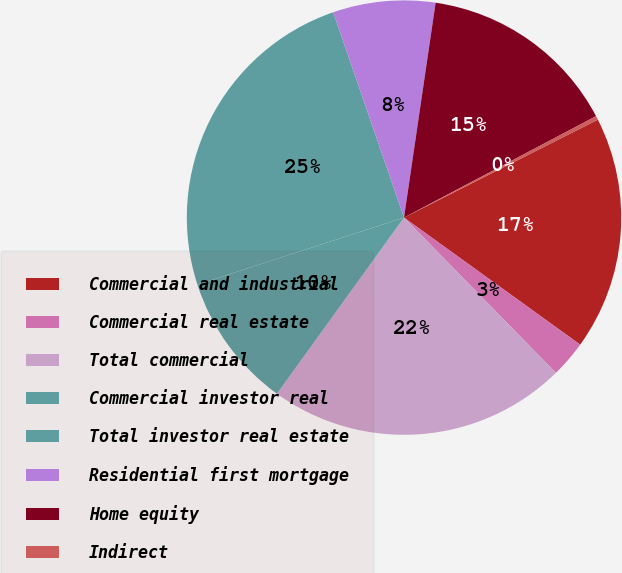Convert chart. <chart><loc_0><loc_0><loc_500><loc_500><pie_chart><fcel>Commercial and industrial<fcel>Commercial real estate<fcel>Total commercial<fcel>Commercial investor real<fcel>Total investor real estate<fcel>Residential first mortgage<fcel>Home equity<fcel>Indirect<nl><fcel>17.39%<fcel>2.73%<fcel>22.27%<fcel>10.06%<fcel>24.71%<fcel>7.61%<fcel>14.94%<fcel>0.29%<nl></chart> 